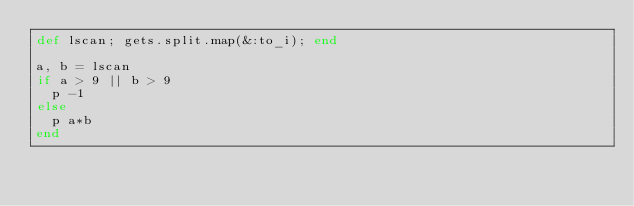Convert code to text. <code><loc_0><loc_0><loc_500><loc_500><_Ruby_>def lscan; gets.split.map(&:to_i); end

a, b = lscan
if a > 9 || b > 9
  p -1
else
  p a*b
end</code> 